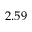Convert formula to latex. <formula><loc_0><loc_0><loc_500><loc_500>2 . 5 9</formula> 